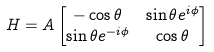<formula> <loc_0><loc_0><loc_500><loc_500>H & = A \begin{bmatrix} - \cos { \theta } & \sin { \theta } e ^ { i \phi } \\ \sin { \theta } e ^ { - i \phi } & \cos { \theta } \end{bmatrix} \\</formula> 